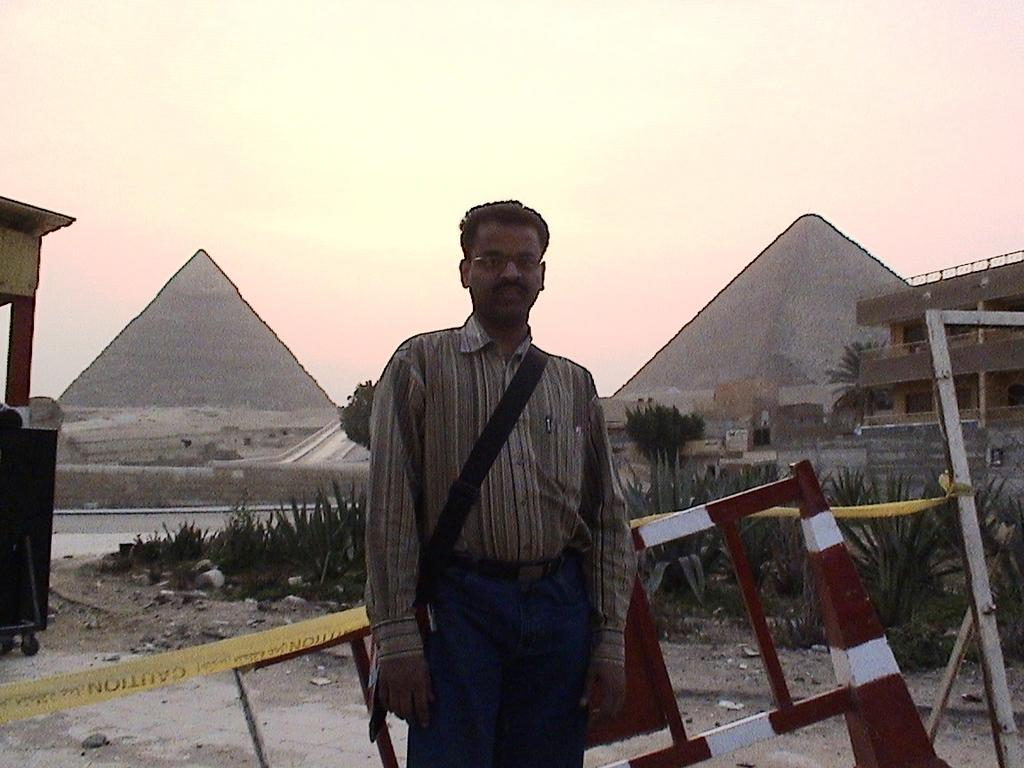What is the main subject in the middle of the image? There is a man in the middle of the image. What is the man wearing? The man is wearing a bag. What can be seen behind the man? There are metal rods visible behind the man. What type of vegetation is present in the image? There are plants and trees in the image. What type of structures can be seen in the image? There are buildings and pyramids in the image. How much does the man's feeling about his hobbies contribute to the overall composition of the image? The image does not provide any information about the man's feelings or hobbies, so it is not possible to determine their contribution to the composition. 